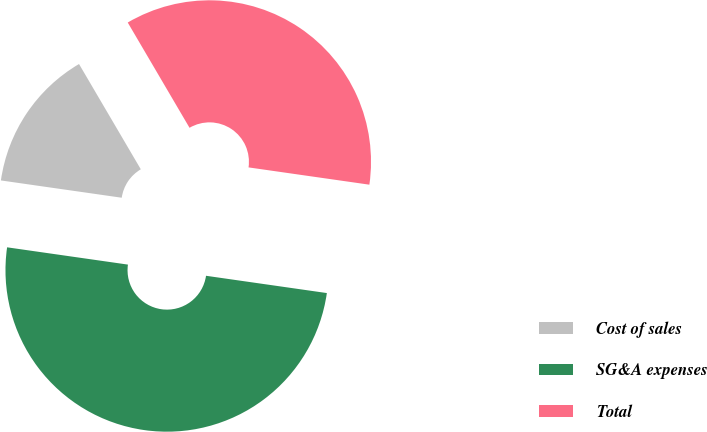<chart> <loc_0><loc_0><loc_500><loc_500><pie_chart><fcel>Cost of sales<fcel>SG&A expenses<fcel>Total<nl><fcel>14.29%<fcel>50.0%<fcel>35.71%<nl></chart> 